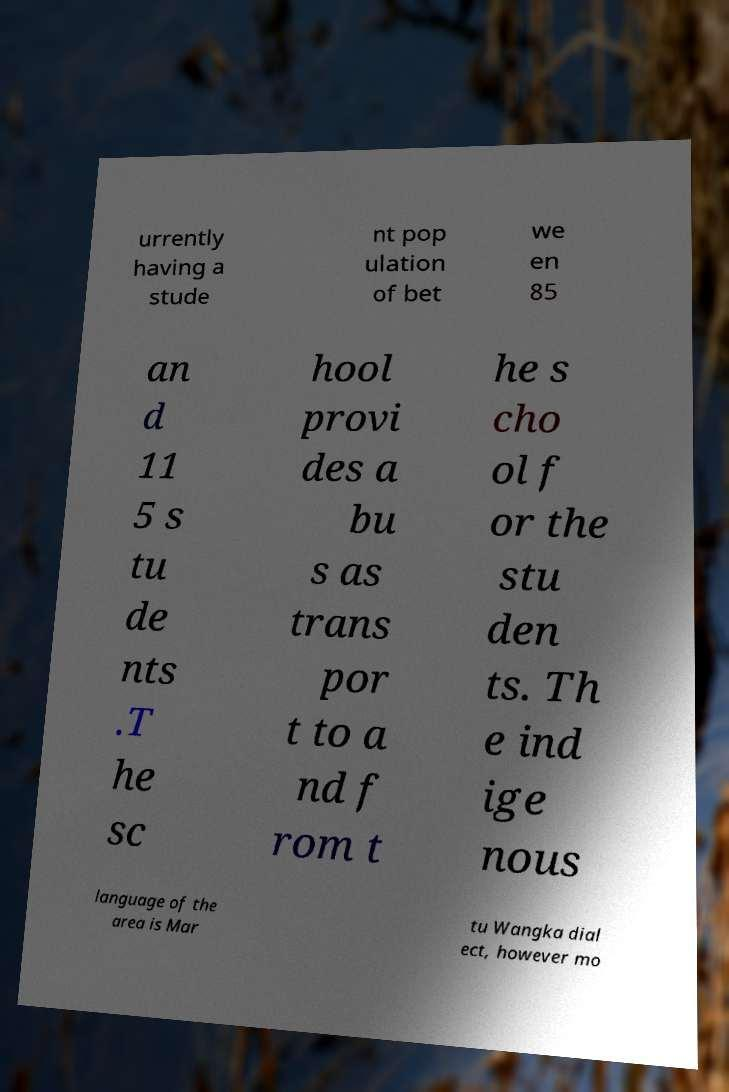I need the written content from this picture converted into text. Can you do that? urrently having a stude nt pop ulation of bet we en 85 an d 11 5 s tu de nts .T he sc hool provi des a bu s as trans por t to a nd f rom t he s cho ol f or the stu den ts. Th e ind ige nous language of the area is Mar tu Wangka dial ect, however mo 